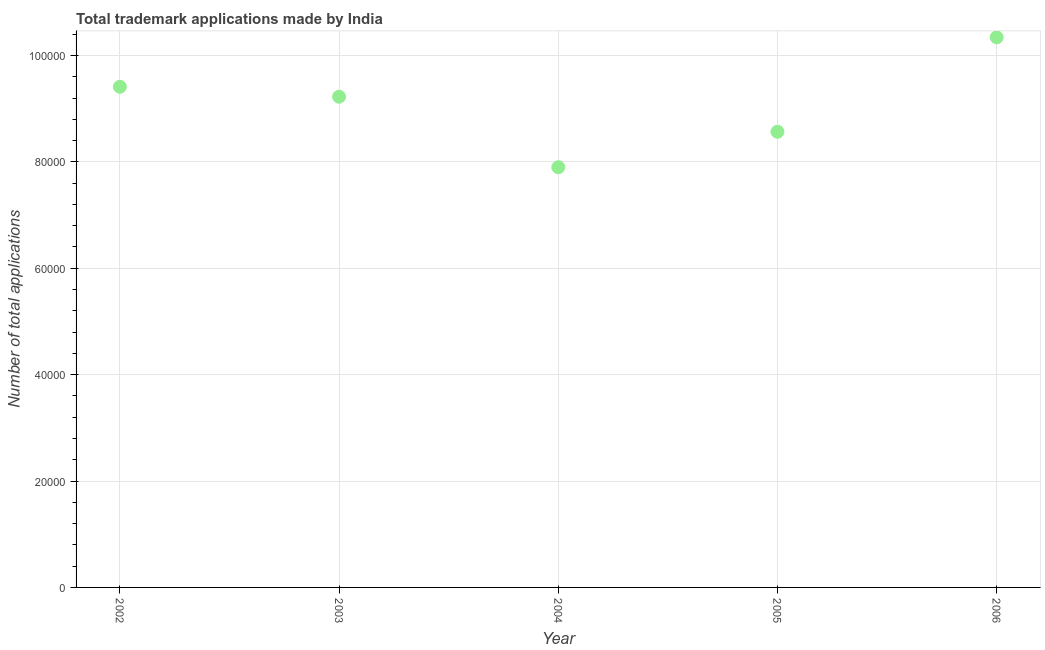What is the number of trademark applications in 2004?
Give a very brief answer. 7.90e+04. Across all years, what is the maximum number of trademark applications?
Your response must be concise. 1.03e+05. Across all years, what is the minimum number of trademark applications?
Make the answer very short. 7.90e+04. In which year was the number of trademark applications maximum?
Your answer should be very brief. 2006. In which year was the number of trademark applications minimum?
Keep it short and to the point. 2004. What is the sum of the number of trademark applications?
Give a very brief answer. 4.54e+05. What is the difference between the number of trademark applications in 2002 and 2003?
Offer a terse response. 1869. What is the average number of trademark applications per year?
Keep it short and to the point. 9.09e+04. What is the median number of trademark applications?
Your response must be concise. 9.23e+04. What is the ratio of the number of trademark applications in 2003 to that in 2006?
Ensure brevity in your answer.  0.89. Is the number of trademark applications in 2002 less than that in 2004?
Provide a succinct answer. No. Is the difference between the number of trademark applications in 2004 and 2006 greater than the difference between any two years?
Keep it short and to the point. Yes. What is the difference between the highest and the second highest number of trademark applications?
Give a very brief answer. 9299. Is the sum of the number of trademark applications in 2004 and 2006 greater than the maximum number of trademark applications across all years?
Your response must be concise. Yes. What is the difference between the highest and the lowest number of trademark applications?
Provide a succinct answer. 2.44e+04. In how many years, is the number of trademark applications greater than the average number of trademark applications taken over all years?
Make the answer very short. 3. What is the title of the graph?
Give a very brief answer. Total trademark applications made by India. What is the label or title of the X-axis?
Your answer should be compact. Year. What is the label or title of the Y-axis?
Provide a succinct answer. Number of total applications. What is the Number of total applications in 2002?
Keep it short and to the point. 9.41e+04. What is the Number of total applications in 2003?
Your response must be concise. 9.23e+04. What is the Number of total applications in 2004?
Give a very brief answer. 7.90e+04. What is the Number of total applications in 2005?
Make the answer very short. 8.57e+04. What is the Number of total applications in 2006?
Give a very brief answer. 1.03e+05. What is the difference between the Number of total applications in 2002 and 2003?
Your response must be concise. 1869. What is the difference between the Number of total applications in 2002 and 2004?
Ensure brevity in your answer.  1.51e+04. What is the difference between the Number of total applications in 2002 and 2005?
Your answer should be compact. 8451. What is the difference between the Number of total applications in 2002 and 2006?
Your answer should be very brief. -9299. What is the difference between the Number of total applications in 2003 and 2004?
Your answer should be very brief. 1.33e+04. What is the difference between the Number of total applications in 2003 and 2005?
Keep it short and to the point. 6582. What is the difference between the Number of total applications in 2003 and 2006?
Make the answer very short. -1.12e+04. What is the difference between the Number of total applications in 2004 and 2005?
Make the answer very short. -6673. What is the difference between the Number of total applications in 2004 and 2006?
Provide a short and direct response. -2.44e+04. What is the difference between the Number of total applications in 2005 and 2006?
Make the answer very short. -1.78e+04. What is the ratio of the Number of total applications in 2002 to that in 2004?
Your response must be concise. 1.19. What is the ratio of the Number of total applications in 2002 to that in 2005?
Your answer should be very brief. 1.1. What is the ratio of the Number of total applications in 2002 to that in 2006?
Provide a succinct answer. 0.91. What is the ratio of the Number of total applications in 2003 to that in 2004?
Provide a succinct answer. 1.17. What is the ratio of the Number of total applications in 2003 to that in 2005?
Your answer should be compact. 1.08. What is the ratio of the Number of total applications in 2003 to that in 2006?
Your response must be concise. 0.89. What is the ratio of the Number of total applications in 2004 to that in 2005?
Ensure brevity in your answer.  0.92. What is the ratio of the Number of total applications in 2004 to that in 2006?
Give a very brief answer. 0.76. What is the ratio of the Number of total applications in 2005 to that in 2006?
Give a very brief answer. 0.83. 